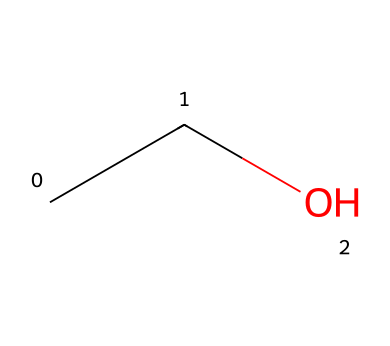How many carbon atoms are in this molecule? The SMILES representation "CCO" indicates that there are two carbon atoms. Each "C" represents one carbon atom, and there are two of them before the "O".
Answer: two What is the chemical name of this compound? The provided SMILES "CCO" corresponds to ethanol, which is the IUPAC name for this simple alcohol.
Answer: ethanol How many hydrogen atoms does this molecule contain? In the structure "CCO", there are a total of six hydrogen atoms. Each carbon atom can bond with enough hydrogen atoms to have four total bonds: The first carbon is connected to three hydrogens, the second carbon is connected to two hydrogens, and the oxygen has one hydrogen bonded to it.
Answer: six What type of functional group is present in this molecule? The SMILES "CCO" indicates the presence of a hydroxyl group (-OH), which characterizes it as an alcohol. Here, the "O" indicates the functional group, highlighting its alcoholic nature.
Answer: hydroxyl Is this molecule polar or non-polar? Ethanol is polar due to the hydroxyl group (-OH), which can form hydrogen bonds with water molecules, making the entire molecule polar because of the electronegativity of oxygen compared to carbon and hydrogen.
Answer: polar What kind of interactions can ethanol engage in with water? Ethanol can engage in hydrogen bonding with water molecules due to its hydroxyl group (-OH), which allows it to mix well with water, demonstrating its polar nature.
Answer: hydrogen bonding Why might ethanol be featured in humorous drinking scenes? Ethanol, as an alcohol, is often associated with social drinking, gatherings, and the funny mishaps that can occur under its influence, hence its frequent portrayal in comedic contexts.
Answer: social drinking 